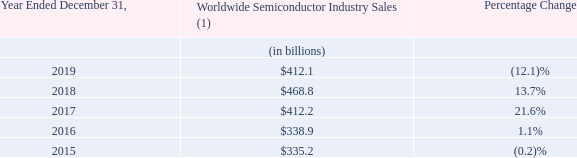Industry Overview
According to WSTS (an industry research firm), worldwide semiconductor industry sales were $412.1 billion in 2019, a decrease of approximately 12.1% from $468.8 billion in 2018. We participate in unit and revenue surveys and use data summarized by WSTS to evaluate overall semiconductor market trends and to track our progress against the market in the areas we provide semiconductor components. The following table sets forth total worldwide semiconductor industry revenue since 2015:
(1) Based on shipment information published by WSTS. We believe the data provided by WSTS is reliable, but we have not independently verified it. WSTS periodically revises its information. We assume no obligation to update such information.
As indicated above, worldwide semiconductor sales increased from $335.2 billion in 2015 to $412.1 billion in 2019. The decrease of 12.1% from 2018 to 2019 was the result of decreased demand for semiconductor products. Our revenue decreased by $360.4 million, or 6.1%, from 2018 to 2019.
How much was the worldwide semiconductor industry sales in 2019? $412.1 billion. How much was the worldwide semiconductor industry sales in 2018? $468.8 billion. What led to the decrease of 12.1% semiconductor sales from 2018 to 2019? Decreased demand for semiconductor products. What is the change in Worldwide Semiconductor Industry Sales from Year Ended December 31, 2018 to 2019?
Answer scale should be: billion. 412.1-468.8
Answer: -56.7. What is the change in Worldwide Semiconductor Industry Sales from Year Ended December 31, 2016 to 2017?
Answer scale should be: billion. 412.2-338.9
Answer: 73.3. What is the average Worldwide Semiconductor Industry Sales for Year Ended December 31, 2018 to 2019?
Answer scale should be: billion. (412.1+468.8) / 2
Answer: 440.45. 